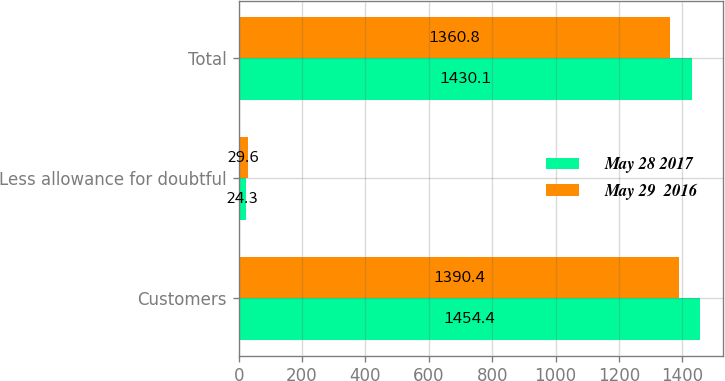Convert chart to OTSL. <chart><loc_0><loc_0><loc_500><loc_500><stacked_bar_chart><ecel><fcel>Customers<fcel>Less allowance for doubtful<fcel>Total<nl><fcel>May 28 2017<fcel>1454.4<fcel>24.3<fcel>1430.1<nl><fcel>May 29  2016<fcel>1390.4<fcel>29.6<fcel>1360.8<nl></chart> 